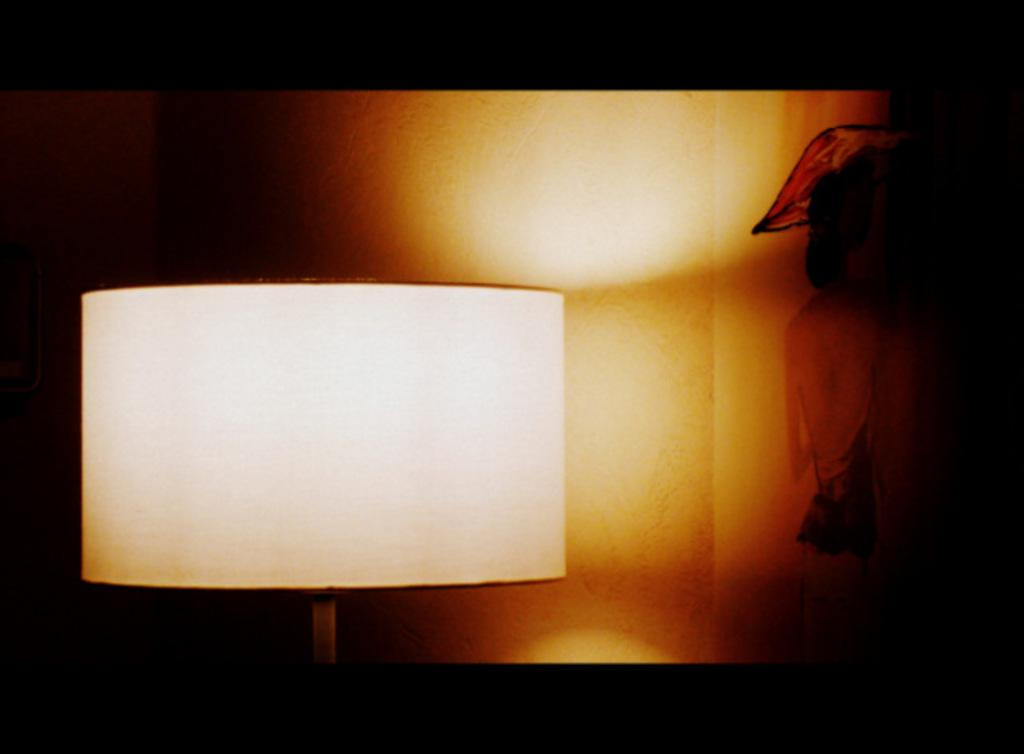What object can be seen in the image? There is a lamp in the image. What colors are present in the background of the image? The background of the image is black, brown, and white in color. How many friends are depicted in the image? There are no friends present in the image; it only features a lamp and a background with black, brown, and white colors. 